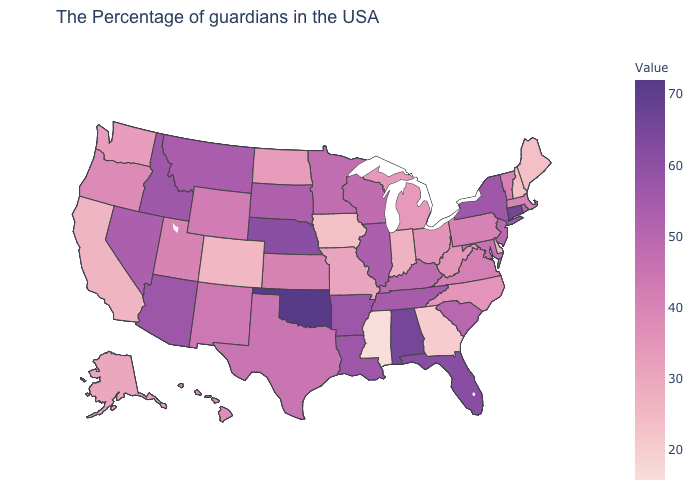Which states hav the highest value in the South?
Be succinct. Oklahoma. Does Minnesota have the highest value in the MidWest?
Quick response, please. No. Among the states that border South Carolina , does North Carolina have the lowest value?
Keep it brief. No. Among the states that border Massachusetts , which have the highest value?
Quick response, please. Connecticut. Does Rhode Island have the lowest value in the USA?
Short answer required. No. Among the states that border North Dakota , which have the highest value?
Keep it brief. Montana. 